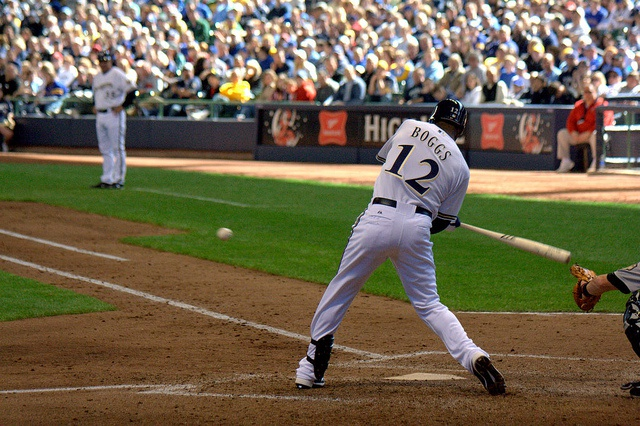Describe the objects in this image and their specific colors. I can see people in darkblue, gray, white, and black tones, people in darkblue, gray, darkgray, and black tones, people in darkblue, darkgray, gray, and black tones, people in darkblue, gray, maroon, and black tones, and baseball bat in darkblue, tan, and gray tones in this image. 